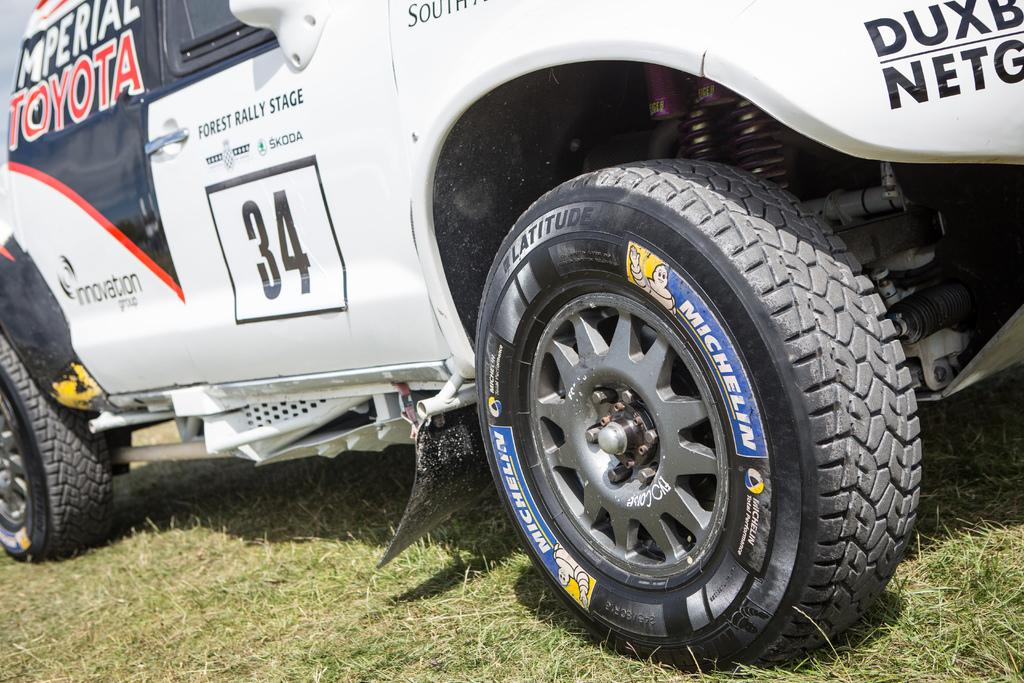What is the main subject of the image? There is a vehicle in the image. What color is the vehicle? The vehicle is white in color. Where is the vehicle located? The vehicle is placed on the grass. What can be seen in the background of the image? There is a sky visible in the image. How many achievers are visible in the image? There is no reference to any achievers in the image; it features a white vehicle placed on the grass with a visible sky in the background. 